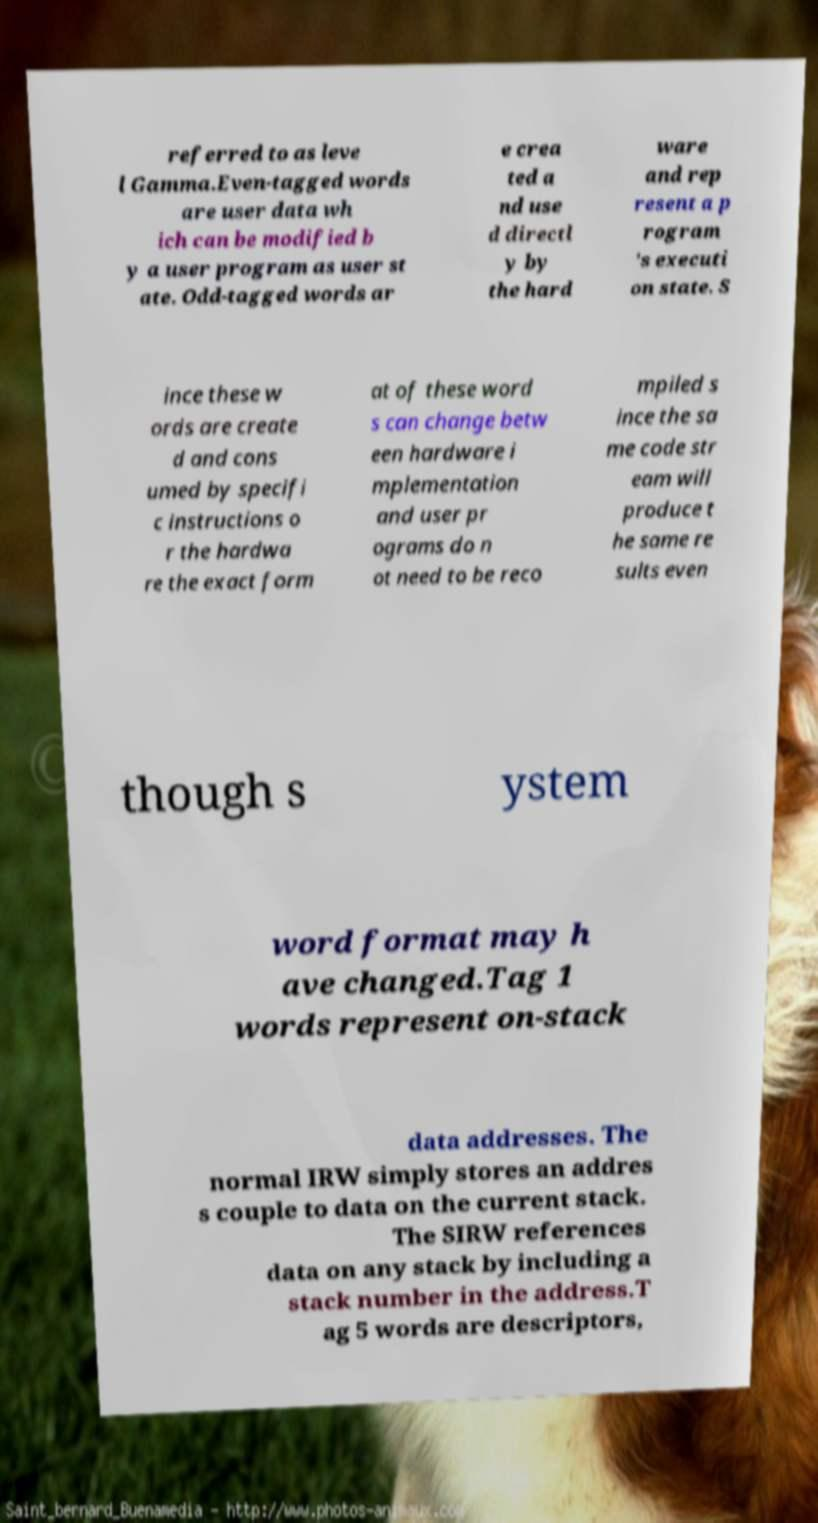I need the written content from this picture converted into text. Can you do that? referred to as leve l Gamma.Even-tagged words are user data wh ich can be modified b y a user program as user st ate. Odd-tagged words ar e crea ted a nd use d directl y by the hard ware and rep resent a p rogram 's executi on state. S ince these w ords are create d and cons umed by specifi c instructions o r the hardwa re the exact form at of these word s can change betw een hardware i mplementation and user pr ograms do n ot need to be reco mpiled s ince the sa me code str eam will produce t he same re sults even though s ystem word format may h ave changed.Tag 1 words represent on-stack data addresses. The normal IRW simply stores an addres s couple to data on the current stack. The SIRW references data on any stack by including a stack number in the address.T ag 5 words are descriptors, 